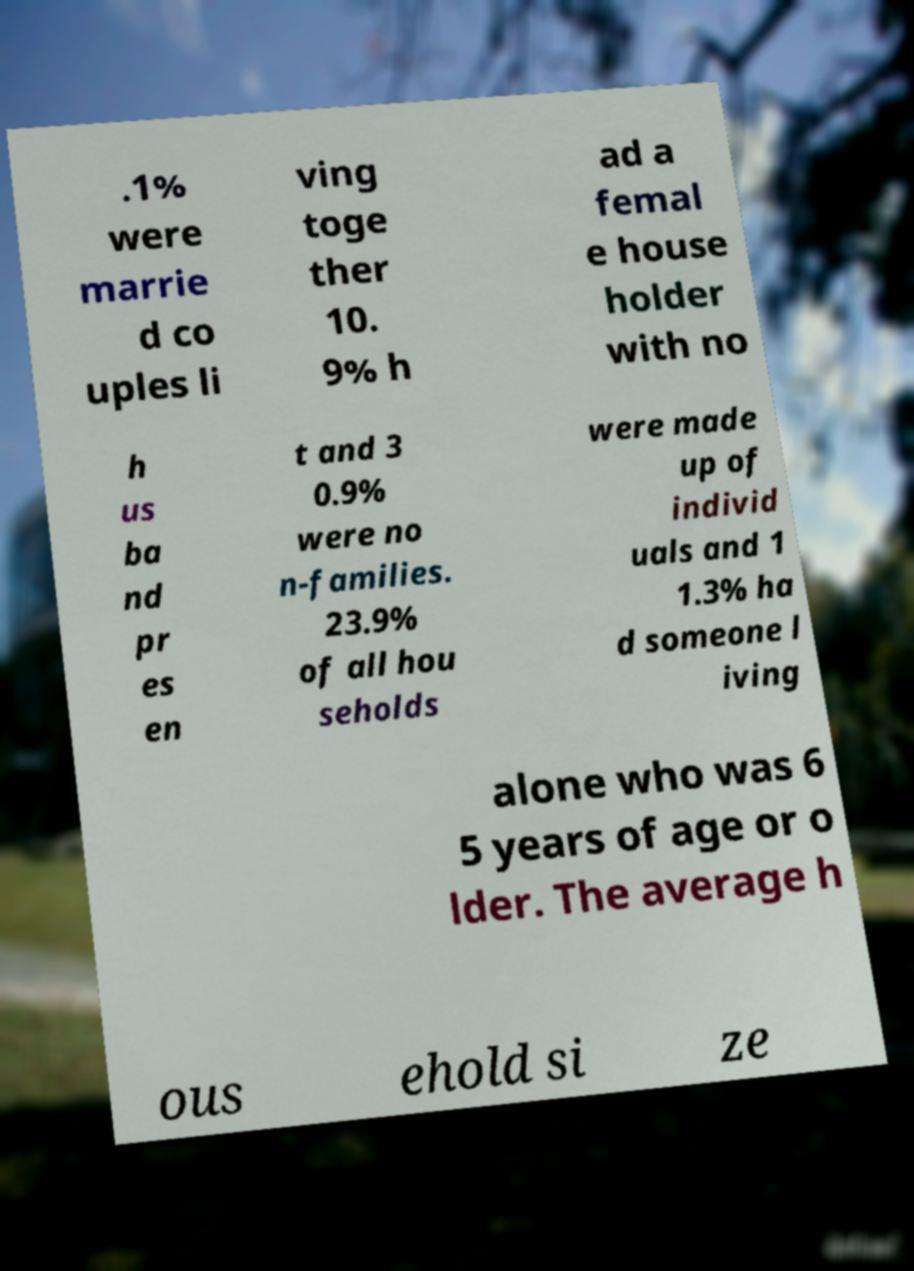For documentation purposes, I need the text within this image transcribed. Could you provide that? .1% were marrie d co uples li ving toge ther 10. 9% h ad a femal e house holder with no h us ba nd pr es en t and 3 0.9% were no n-families. 23.9% of all hou seholds were made up of individ uals and 1 1.3% ha d someone l iving alone who was 6 5 years of age or o lder. The average h ous ehold si ze 